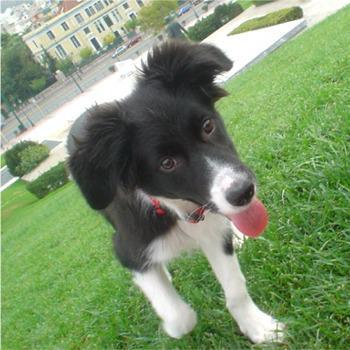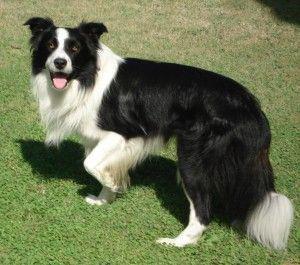The first image is the image on the left, the second image is the image on the right. Assess this claim about the two images: "a dog is looking at the cameral with a brick wall behind it". Correct or not? Answer yes or no. No. The first image is the image on the left, the second image is the image on the right. Examine the images to the left and right. Is the description "A black and white dog with black spots is standing on the ground outside." accurate? Answer yes or no. No. 